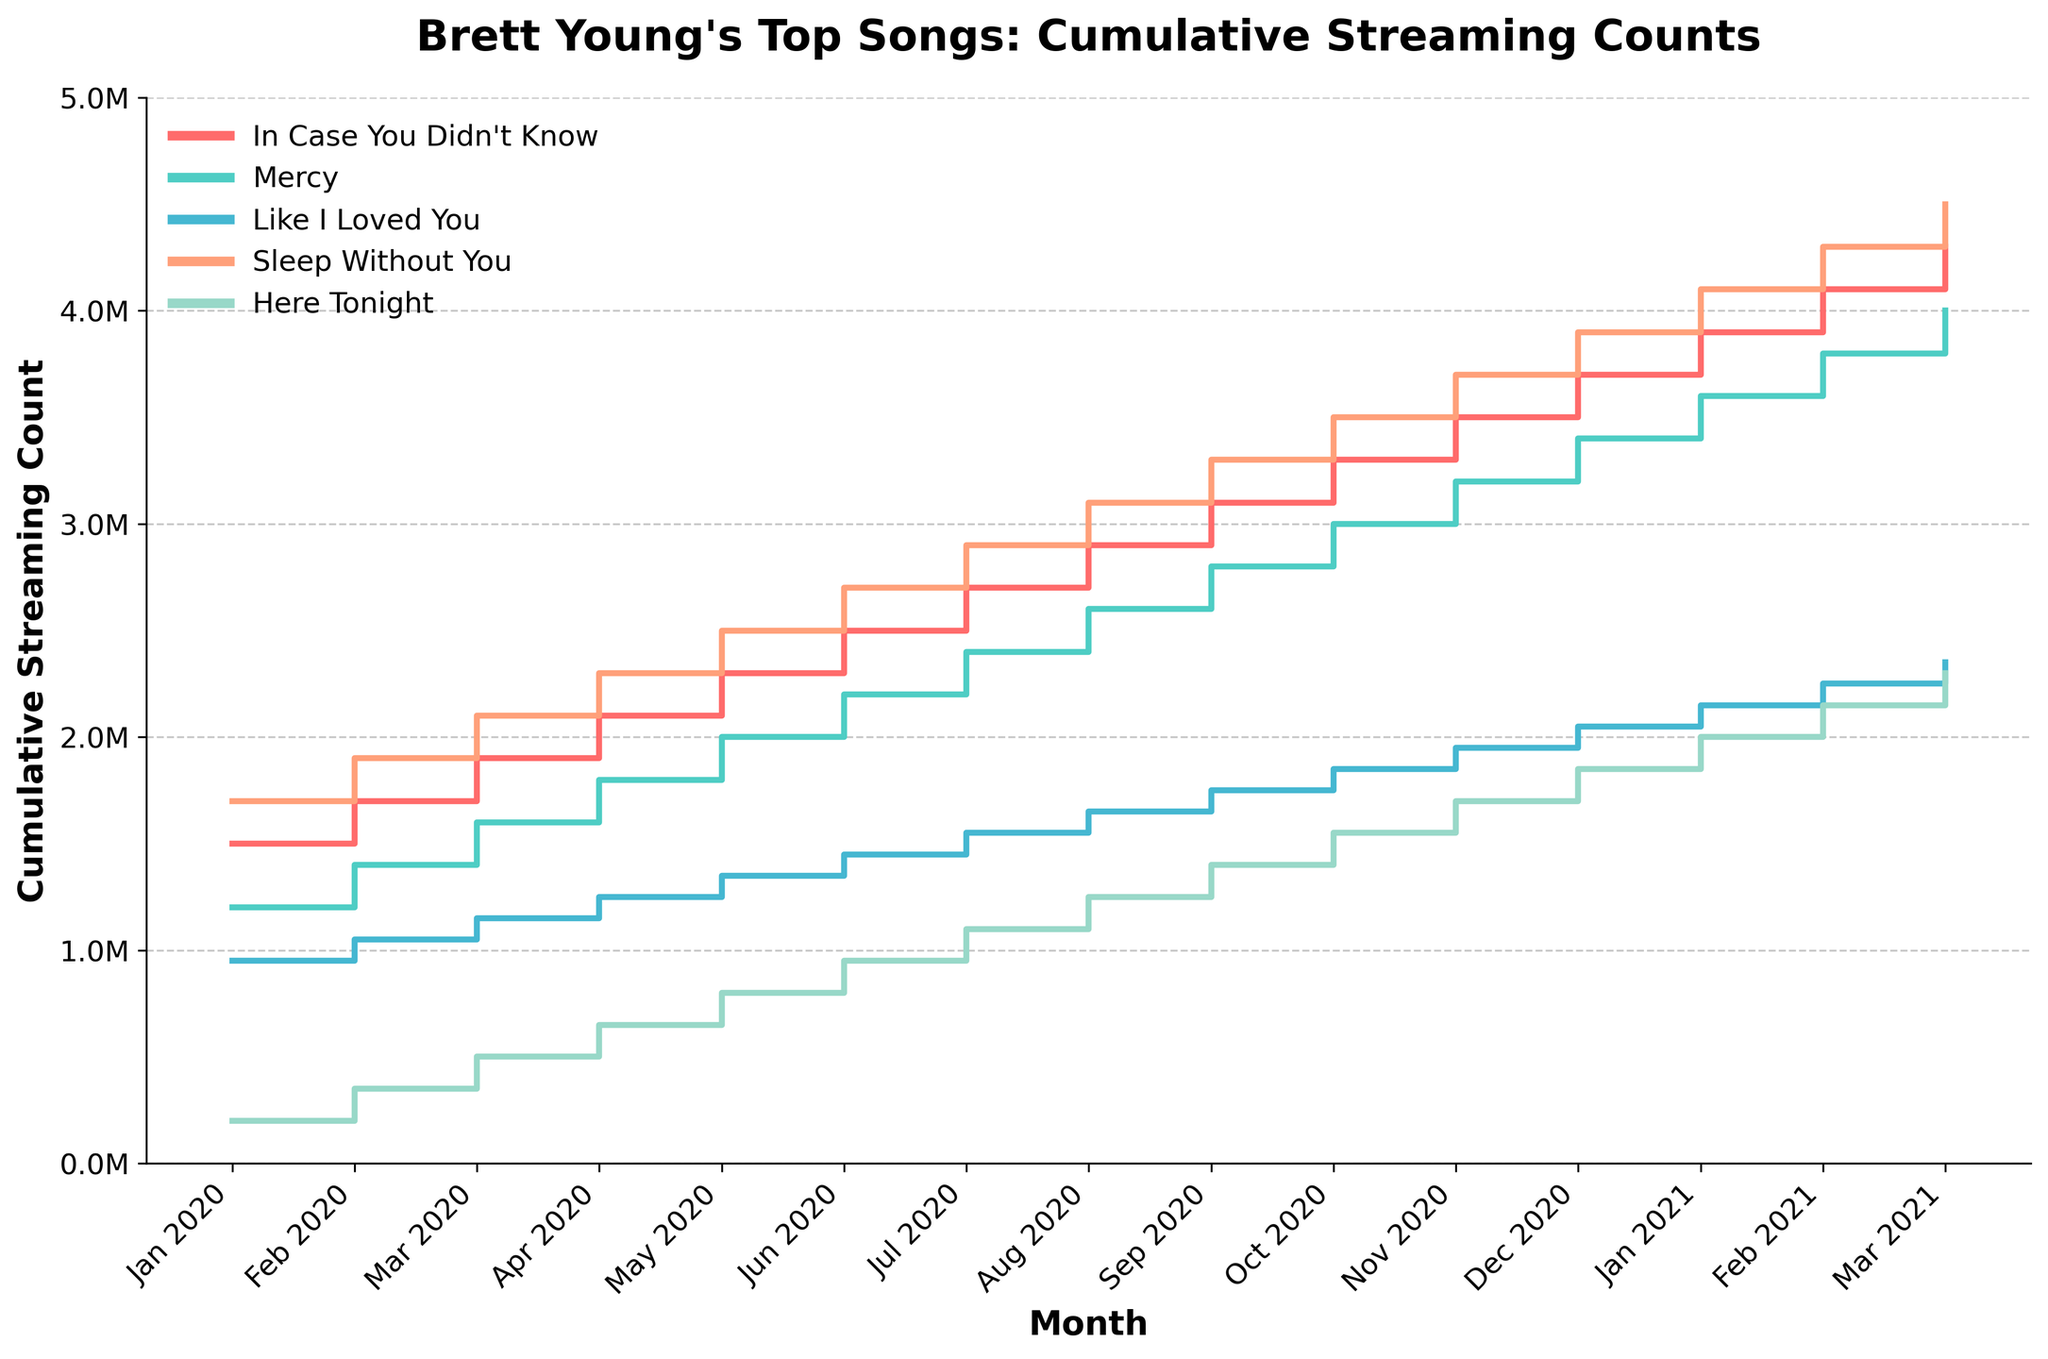What's the title of the plot? The title of the plot is displayed at the top in bold text.
Answer: Brett Young's Top Songs: Cumulative Streaming Counts What songs are represented by different colors in the plot? Each song is represented by a different color in the plot: In Case You Didn't Know (red), Mercy (aqua), Like I Loved You (blue), Sleep Without You (salmon), Here Tonight (light green).
Answer: In Case You Didn't Know, Mercy, Like I Loved You, Sleep Without You, Here Tonight Which song has the highest cumulative streaming count in Mar 2021? In Mar 2021, find the highest value among all songs' cumulative streaming counts and identify the corresponding song.
Answer: Sleep Without You How many months of data are displayed for Brett Young's top songs? Count the number of data points along the x-axis labeled "Month".
Answer: 15 Which song had the fastest cumulative growth between Jan 2020 and Mar 2021? By comparing the increase in streaming counts over the period, identify the song with the largest growth. Sleep Without You had the highest increase from 1.7M to 4.5M.
Answer: Sleep Without You What was the cumulative streaming count for "Here Tonight" in Jun 2020? Read the value of "Here Tonight" at Jun 2020 from the y-axis of the plot.
Answer: 950,000 Between Feb 2020 and Dec 2020, which song showed the least growth in cumulative streaming counts? Calculate the difference between cumulative counts for each song at these two time points and identify the smallest increase.
Answer: Like I Loved You Which two songs have cumulative streaming counts closest to each other in Oct 2020? Identify the two songs with the smallest difference in cumulative streaming counts in Oct 2020.
Answer: Like I Loved You and Here Tonight What is the average cumulative streaming count for "In Case You Didn't Know" from Jan 2020 to Mar 2021? Sum the cumulative streaming counts for "In Case You Didn't Know" from Jan 2020 to Mar 2021 and divide by the number of months (15). \((1500000 + 1700000 + ... + 4300000) / 15 = 2900000\)
Answer: 2,900,000 Which song crossed the 2 million cumulative streaming count first? Identify the first song to reach a y-value greater than 2,000,000 on the plot.
Answer: Sleep Without You 